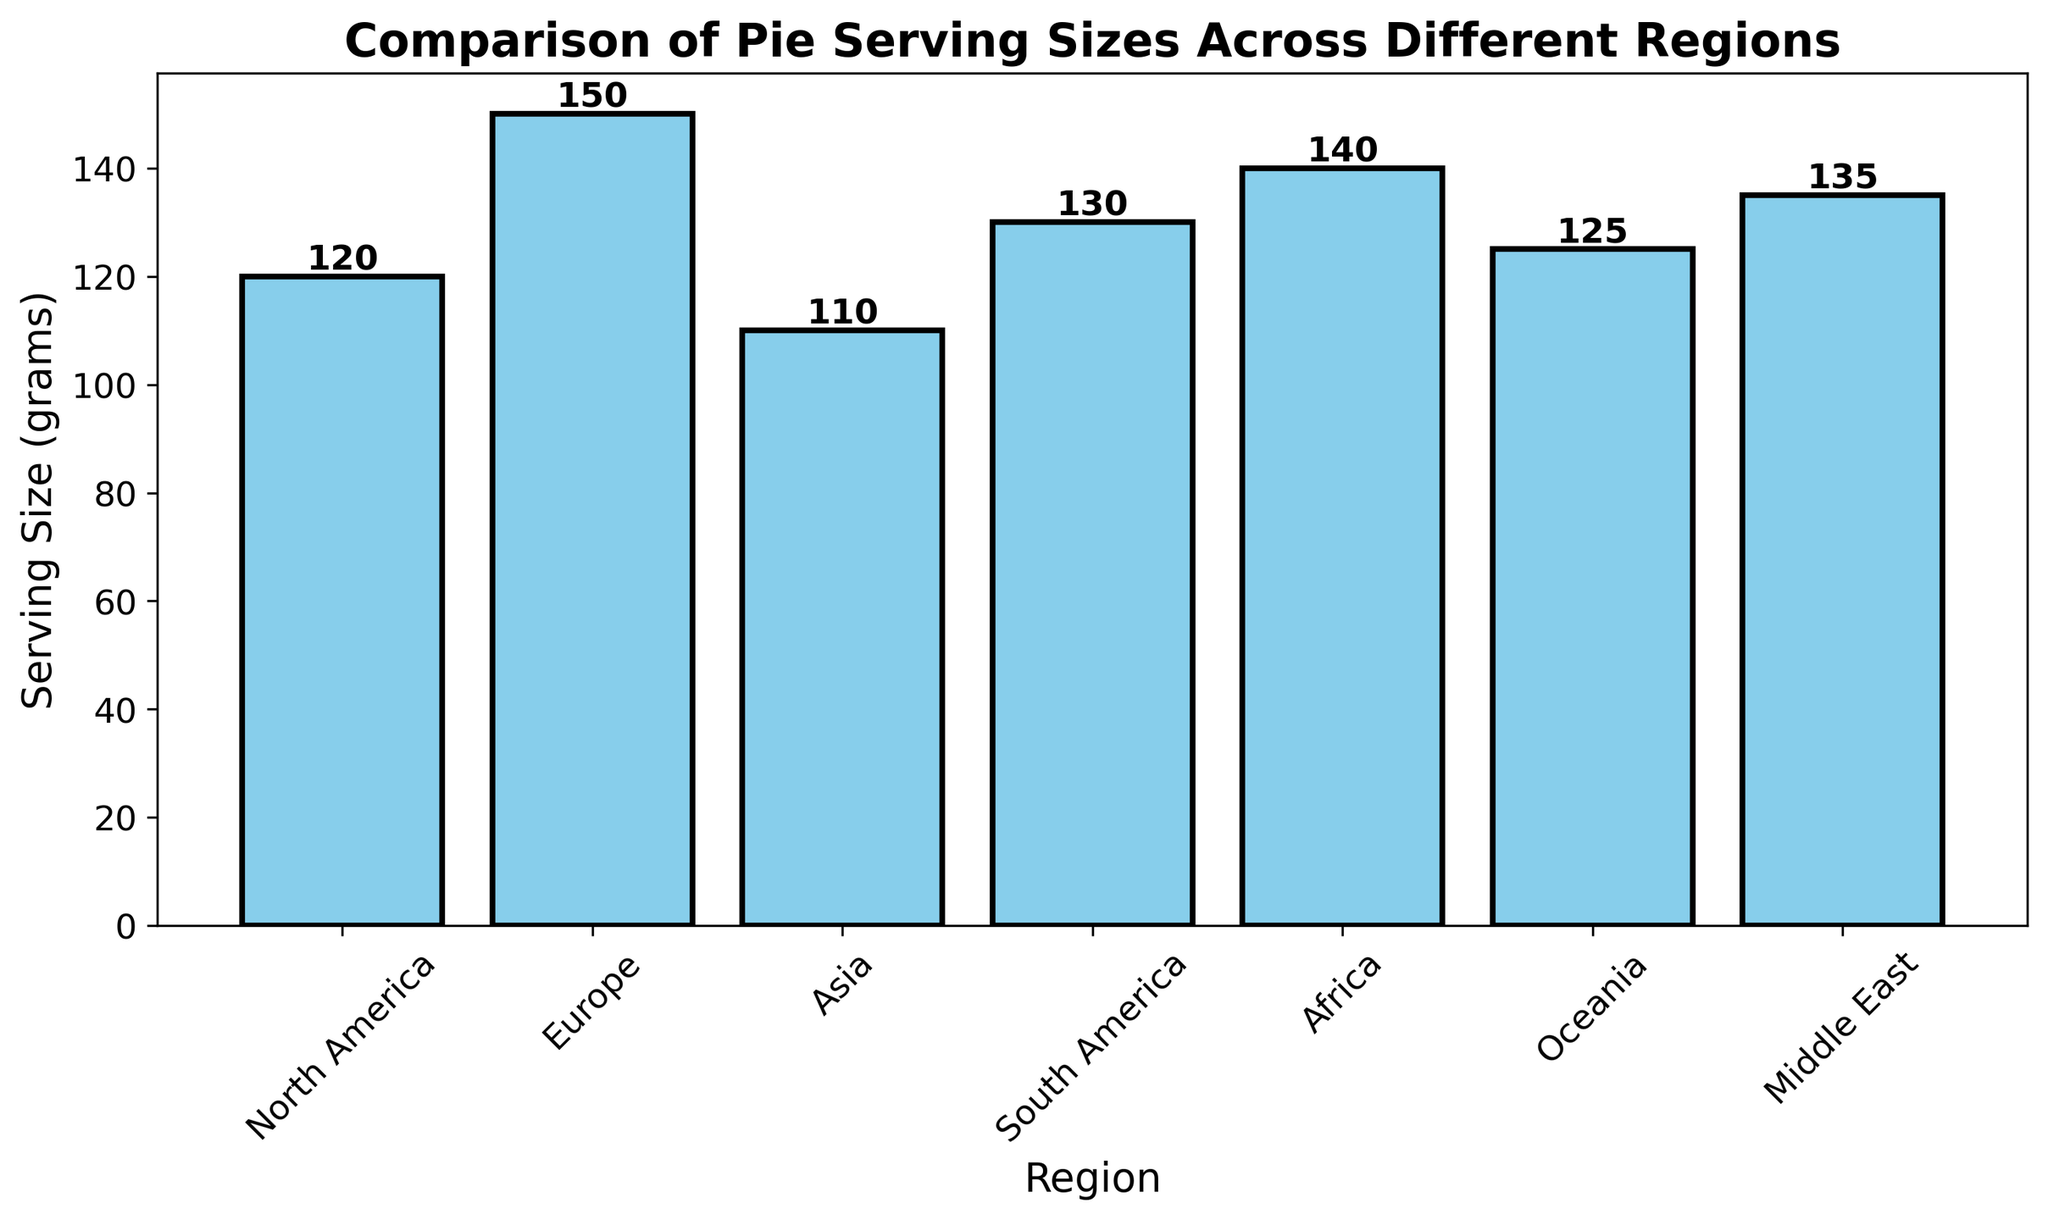What's the region with the largest serving size of pie? First look at the bar heights corresponding to each region. The tallest bar represents Europe with a serving size of 150 grams.
Answer: Europe How much larger is the serving size in Europe compared to Asia? Look at the serving sizes for Europe (150 grams) and Asia (110 grams). Subtract the serving size of Asia from Europe: 150 - 110 = 40 grams.
Answer: 40 grams Which region has the smallest serving size? Identify the bar with the smallest height. The smallest bar represents Asia with 110 grams.
Answer: Asia What’s the average serving size across all regions? Add up the serving sizes and divide by the number of regions: (120 + 150 + 110 + 130 + 140 + 125 + 135) / 7 = 910 / 7 ≈ 130 grams.
Answer: 130 grams Is the serving size in Oceania greater than in North America? Compare the serving sizes for Oceania (125 grams) and North America (120 grams). Since 125 > 120, the serving size in Oceania is greater.
Answer: Yes Rank the regions from highest to lowest serving size. Order the serving sizes: Europe (150 grams), Africa (140 grams), Middle East (135 grams), South America (130 grams), Oceania (125 grams), North America (120 grams), Asia (110 grams).
Answer: Europe, Africa, Middle East, South America, Oceania, North America, Asia How many regions have a serving size larger than 130 grams? Identify regions with serving sizes over 130 grams: Europe (150 grams), Africa (140 grams), Middle East (135 grams). There are 3 regions.
Answer: 3 regions What is the total serving size for North America, South America, and Oceania combined? Add the serving sizes for North America (120 grams), South America (130 grams), and Oceania (125 grams): 120 + 130 + 125 = 375 grams.
Answer: 375 grams By how many grams does Africa exceed Oceania in serving size? Compare the serving sizes: Africa (140 grams) and Oceania (125 grams). Subtract Oceania from Africa: 140 - 125 = 15 grams.
Answer: 15 grams 